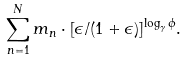Convert formula to latex. <formula><loc_0><loc_0><loc_500><loc_500>\sum _ { n = 1 } ^ { N } m _ { n } \cdot [ \epsilon / ( 1 + \epsilon ) ] ^ { \log _ { \gamma } \phi } .</formula> 